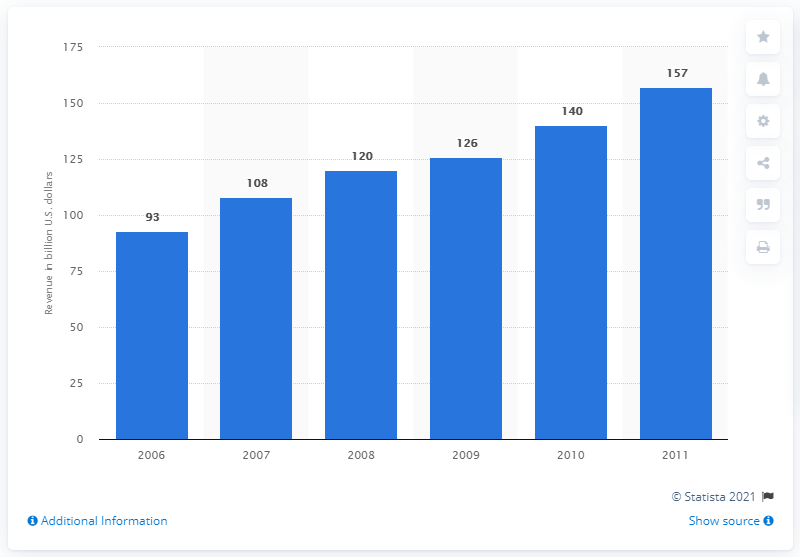Mention a couple of crucial points in this snapshot. Biopharmaceuticals generated approximately 93 billion US dollars in revenue worldwide in 2006. 